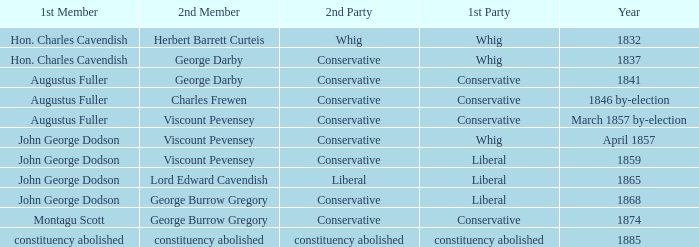Could you parse the entire table as a dict? {'header': ['1st Member', '2nd Member', '2nd Party', '1st Party', 'Year'], 'rows': [['Hon. Charles Cavendish', 'Herbert Barrett Curteis', 'Whig', 'Whig', '1832'], ['Hon. Charles Cavendish', 'George Darby', 'Conservative', 'Whig', '1837'], ['Augustus Fuller', 'George Darby', 'Conservative', 'Conservative', '1841'], ['Augustus Fuller', 'Charles Frewen', 'Conservative', 'Conservative', '1846 by-election'], ['Augustus Fuller', 'Viscount Pevensey', 'Conservative', 'Conservative', 'March 1857 by-election'], ['John George Dodson', 'Viscount Pevensey', 'Conservative', 'Whig', 'April 1857'], ['John George Dodson', 'Viscount Pevensey', 'Conservative', 'Liberal', '1859'], ['John George Dodson', 'Lord Edward Cavendish', 'Liberal', 'Liberal', '1865'], ['John George Dodson', 'George Burrow Gregory', 'Conservative', 'Liberal', '1868'], ['Montagu Scott', 'George Burrow Gregory', 'Conservative', 'Conservative', '1874'], ['constituency abolished', 'constituency abolished', 'constituency abolished', 'constituency abolished', '1885']]} In 1837, who was the 2nd member who's 2nd party was conservative. George Darby. 